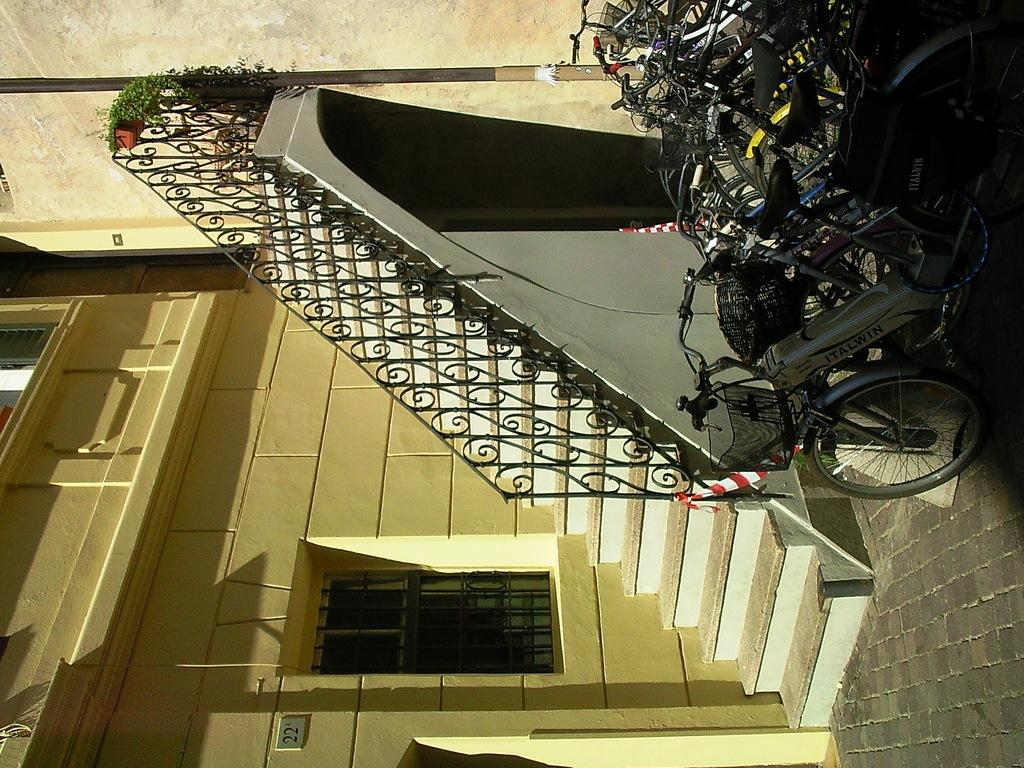What type of vehicles are in the image? There are bicycles in the image. What architectural feature is present in the image? There is a staircase in the image. What type of structure is depicted in the image? The image contains a building. What can be seen through the window in the image? There is no information about what can be seen through the window in the image. What type of clothing is visible in the image? Pants are visible in the image. What vertical structure is present in the image? There is a pole in the image. What flat, rectangular object is present in the image? There is a board in the image. What type of bomb is depicted in the image? There is no bomb present in the image. Can you describe the fairies flying around the bicycles in the image? There are no fairies present in the image. 